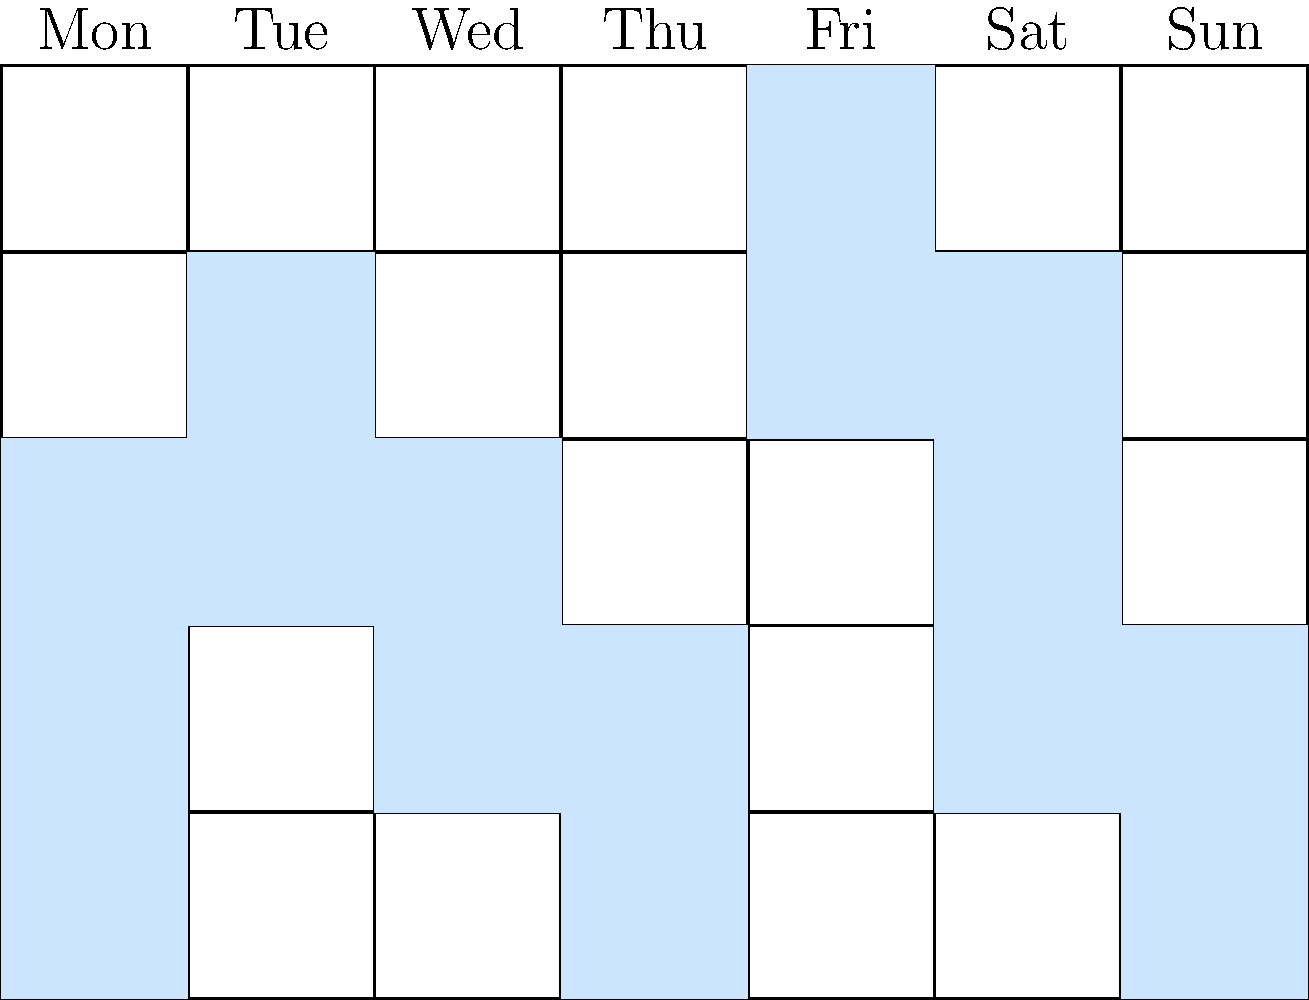Based on the weekly volunteer schedule shown in the grid, where each filled cell represents a 2-hour shift, on which day of the week is there the least amount of volunteer coverage? To determine the day with the least volunteer coverage, we need to count the number of filled cells (representing 2-hour shifts) for each day:

1. Monday: 3 filled cells = 6 hours
2. Tuesday: 2 filled cells = 4 hours
3. Wednesday: 2 filled cells = 4 hours
4. Thursday: 2 filled cells = 4 hours
5. Friday: 2 filled cells = 4 hours
6. Saturday: 3 filled cells = 6 hours
7. Sunday: 2 filled cells = 4 hours

The days with the least coverage are Tuesday, Wednesday, Thursday, Friday, and Sunday, each with 4 hours of coverage. However, the question asks for a single day, so we need to choose one of these days.

In animal shelter management, weekends often require more volunteer support due to increased adoption events and visitor traffic. Given this context, and considering that Sunday has the same low coverage as some weekdays, Sunday would be the most critical day to address in terms of insufficient volunteer coverage.
Answer: Sunday 